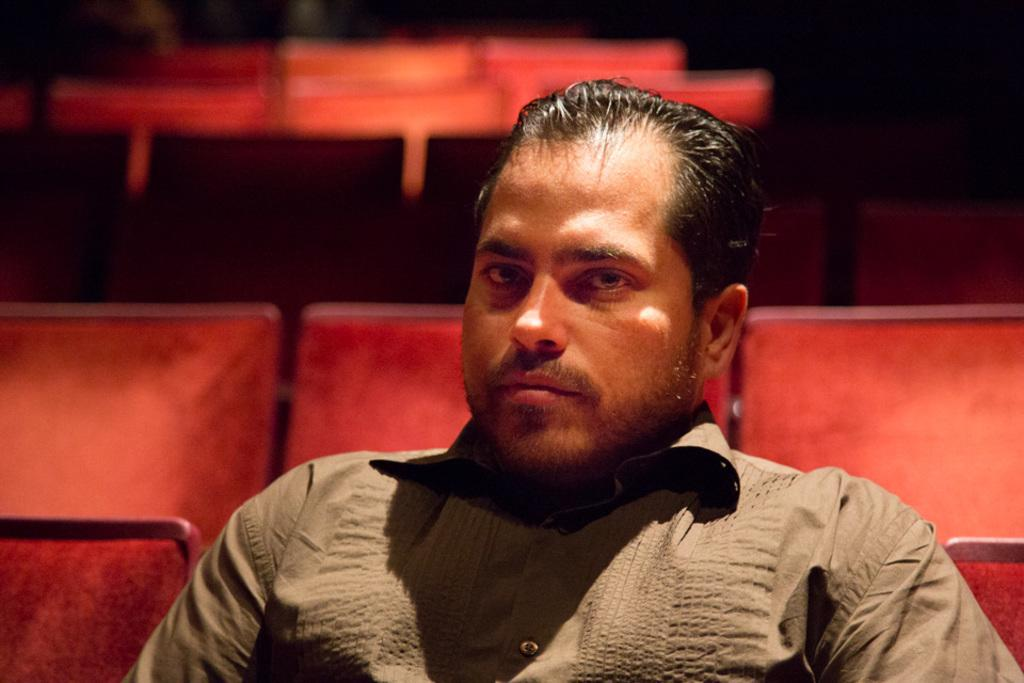What is present in the image? There is a man in the image. What is the man doing in the image? The man is seated on a chair. Are there any other chairs visible in the image? Yes, there are empty chairs in the image. What type of lace can be seen on the edge of the plot in the image? There is no lace or plot present in the image; it features a man seated on a chair with empty chairs nearby. 